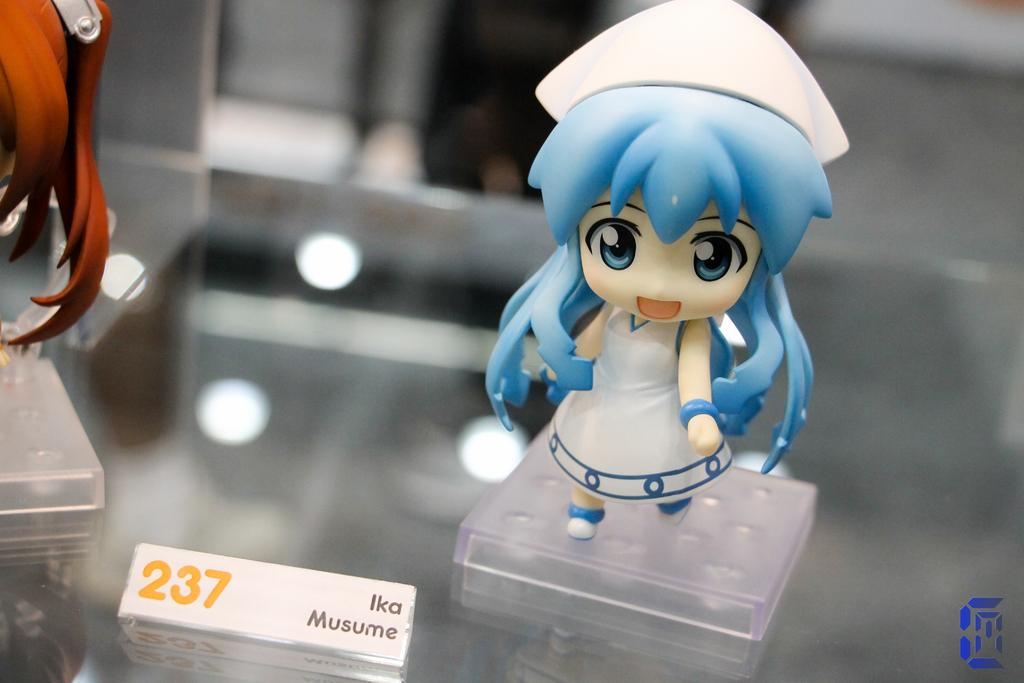What object in the image is typically associated with play or entertainment? There is a toy in the image. What other object can be seen in the image, attached to a glass surface? There is a name board on the glass in the image. Where is the nearest mailbox to the toy in the image? There is no mailbox present in the image. What is the distance between the toy and downtown in the image? There is no reference to downtown in the image, so it is not possible to determine the distance between the toy and downtown. 